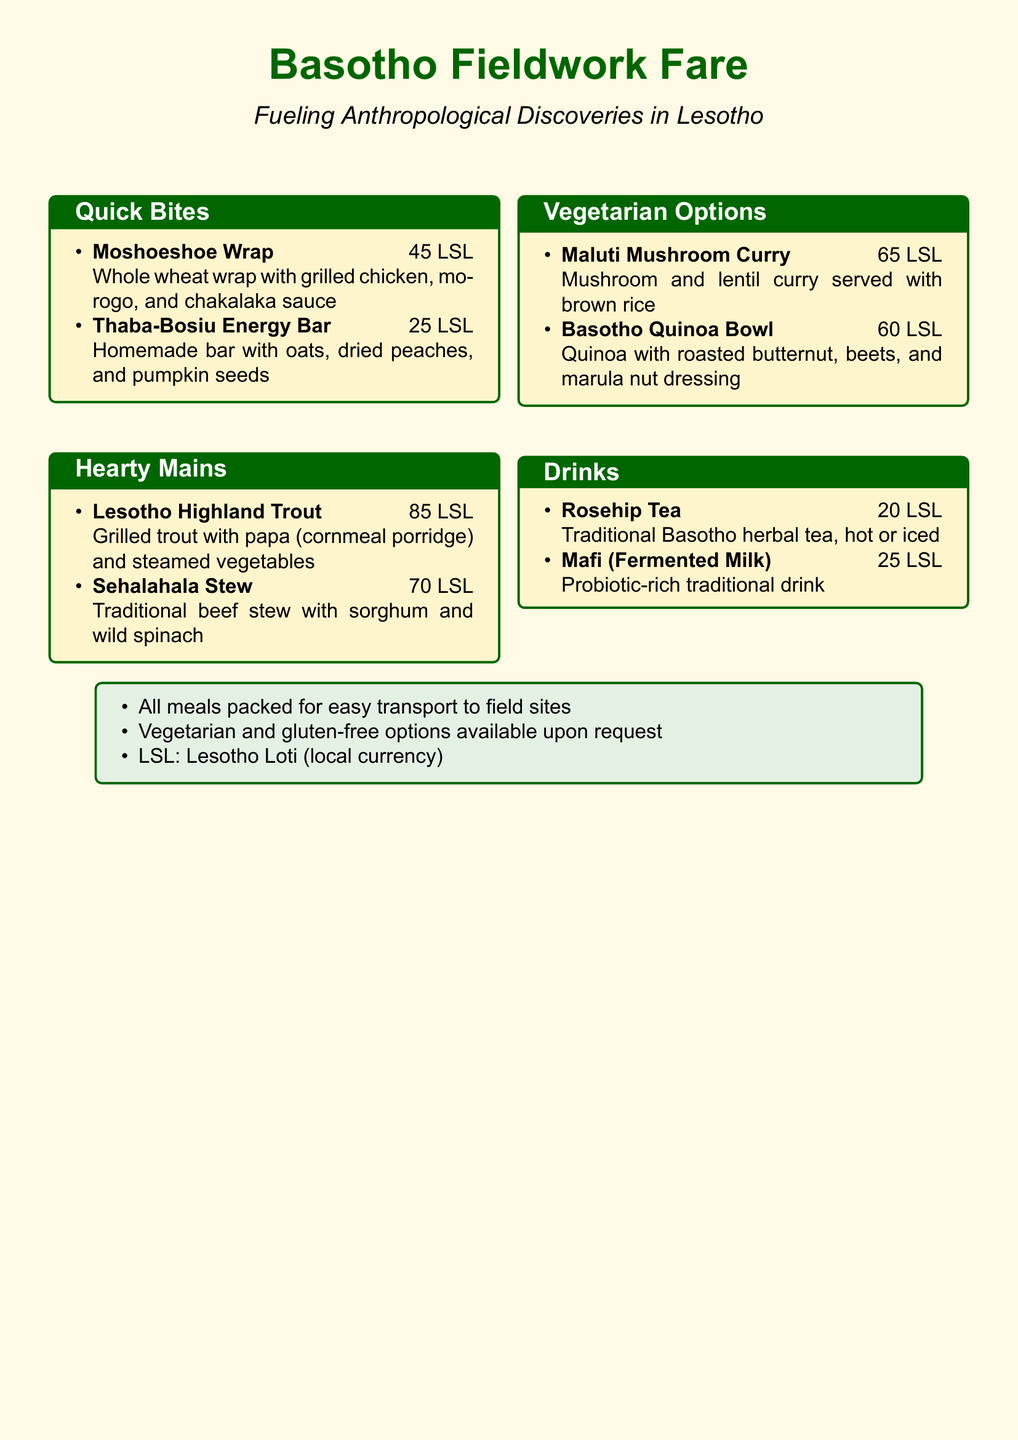What is the price of the Moshoeshoe Wrap? The price of the Moshoeshoe Wrap is specifically indicated in the menu section for Quick Bites.
Answer: 45 LSL What is included in the Lesotho Highland Trout dish? The Lesotho Highland Trout dish contains grilled trout, papa, and steamed vegetables as listed under Hearty Mains.
Answer: Grilled trout with papa and steamed vegetables How much does the Basotho Quinoa Bowl cost? The cost of the Basotho Quinoa Bowl can be found in the Vegetarian Options section.
Answer: 60 LSL What type of drink is Mafi? The Mafi drink is described as a traditional drink that is probiotic-rich, mentioned in the Drinks section.
Answer: Fermented milk Which meal is specifically vegetarian? The menu lists vegetarian options, and the Maluti Mushroom Curry is one of them.
Answer: Maluti Mushroom Curry How many categories are a part of the menu? The document contains four categories that list different types of meals and drinks.
Answer: Four What does LSL stand for? LSL is defined at the bottom of the menu, indicating the local currency used in Lesotho.
Answer: Lesotho Loti Which dish features wild spinach? The dish that features wild spinach is mentioned in relation to the traditional beef stew in the Hearty Mains section.
Answer: Sehalahala Stew What kind of options are available upon request? The menu specifies that vegetarian and gluten-free options are available upon request.
Answer: Vegetarian and gluten-free options 